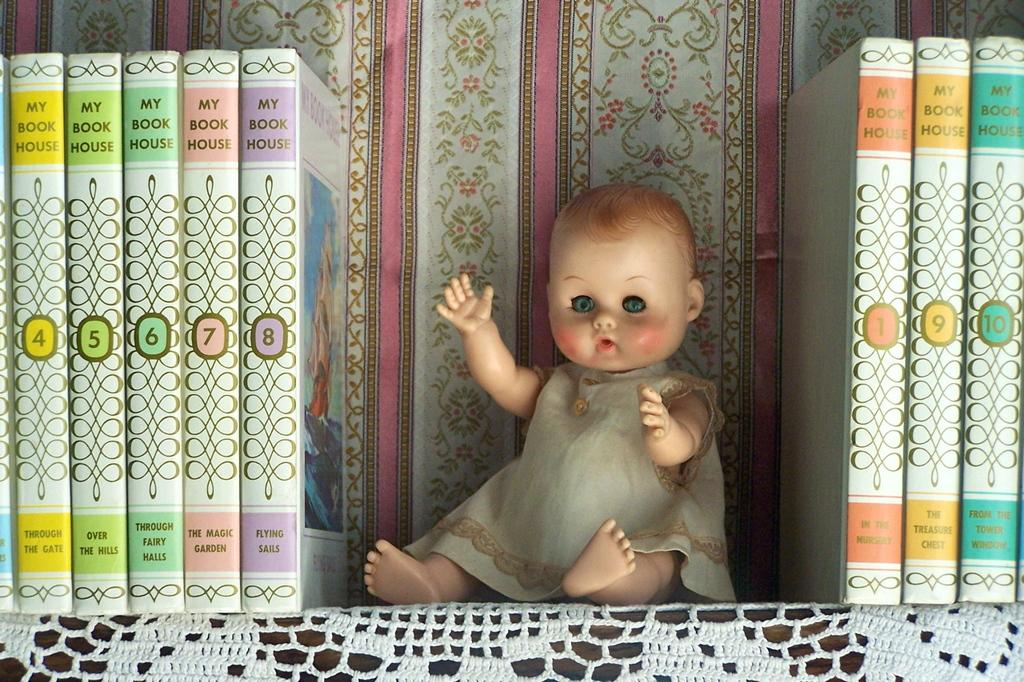Provide a one-sentence caption for the provided image. A row of My Book House editions books with the numbers 4-10 on the books and a doll in the middle. 